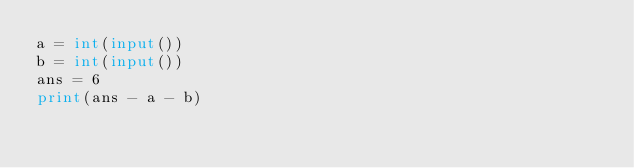<code> <loc_0><loc_0><loc_500><loc_500><_Python_>a = int(input())
b = int(input())
ans = 6
print(ans - a - b)
</code> 